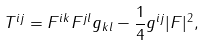Convert formula to latex. <formula><loc_0><loc_0><loc_500><loc_500>T ^ { i j } = F ^ { i k } F ^ { j l } g _ { k l } - { \frac { 1 } { 4 } } g ^ { i j } | F | ^ { 2 } ,</formula> 